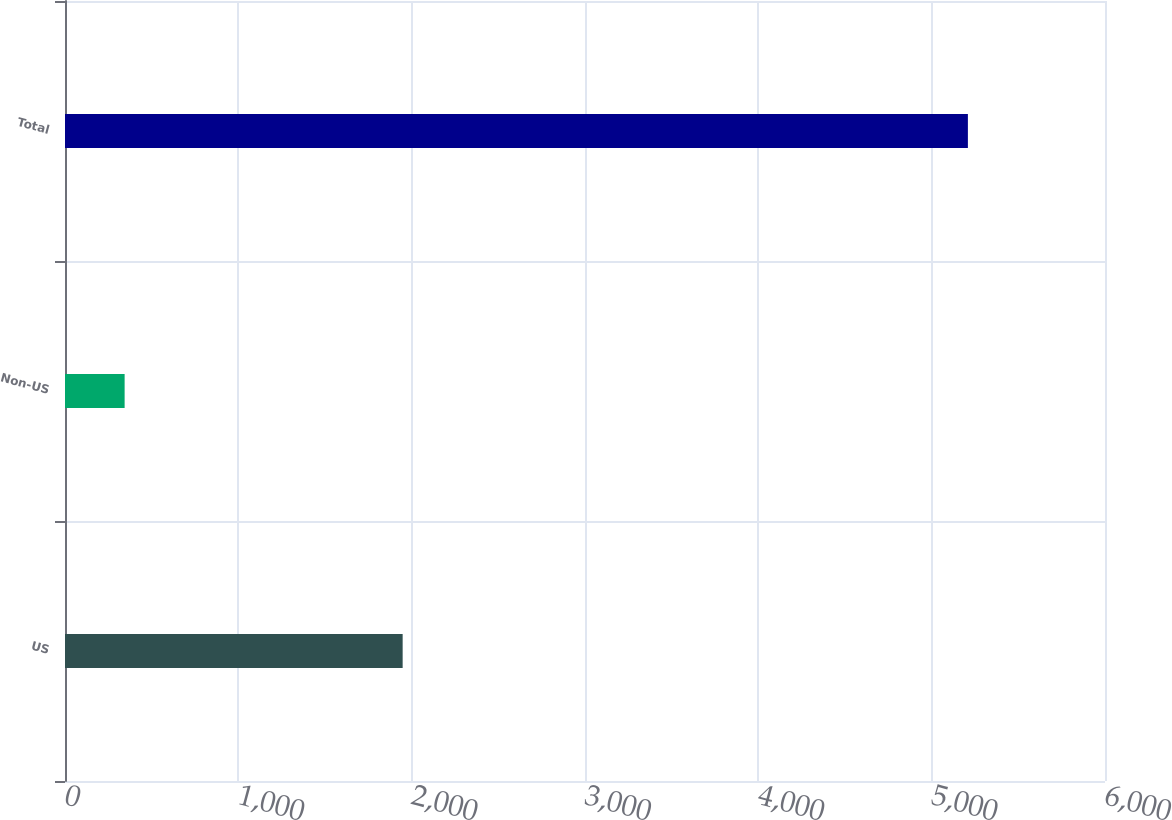Convert chart. <chart><loc_0><loc_0><loc_500><loc_500><bar_chart><fcel>US<fcel>Non-US<fcel>Total<nl><fcel>1948<fcel>344<fcel>5209<nl></chart> 